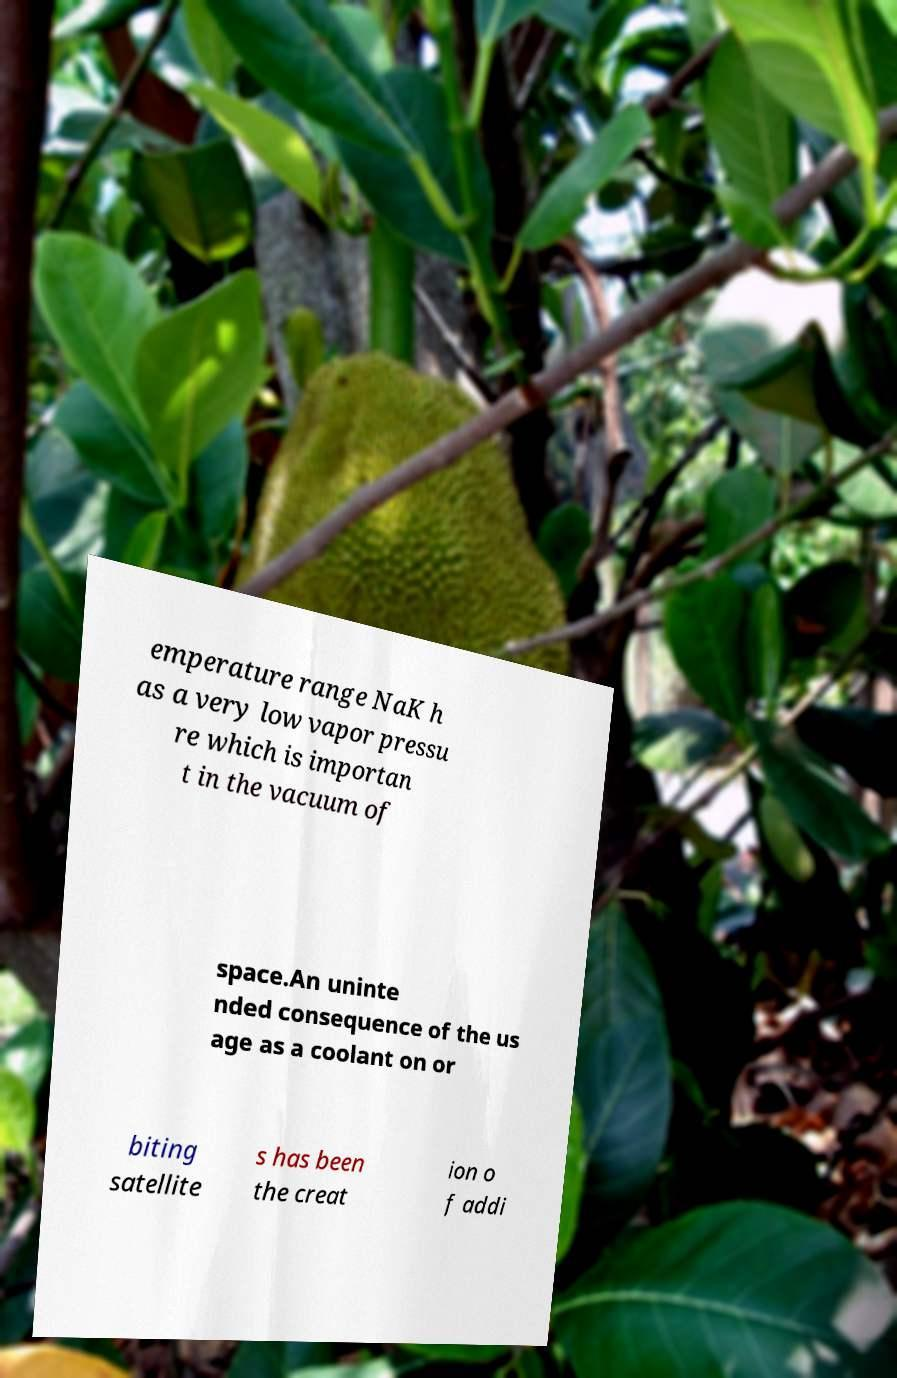Can you accurately transcribe the text from the provided image for me? emperature range NaK h as a very low vapor pressu re which is importan t in the vacuum of space.An uninte nded consequence of the us age as a coolant on or biting satellite s has been the creat ion o f addi 